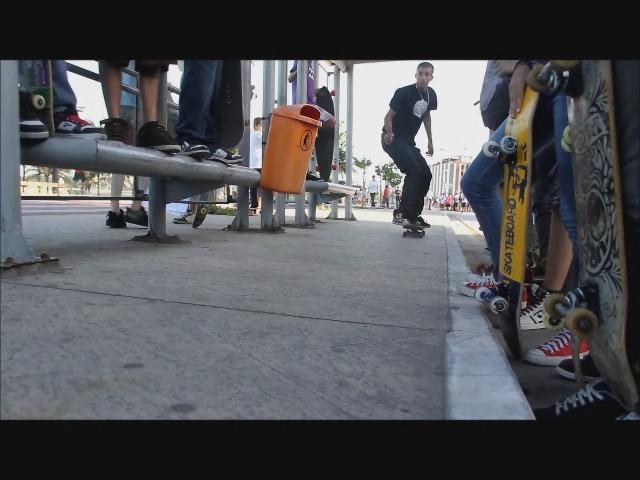What is the orange object used for? Please explain your reasoning. trash. It's used for a trash can. 